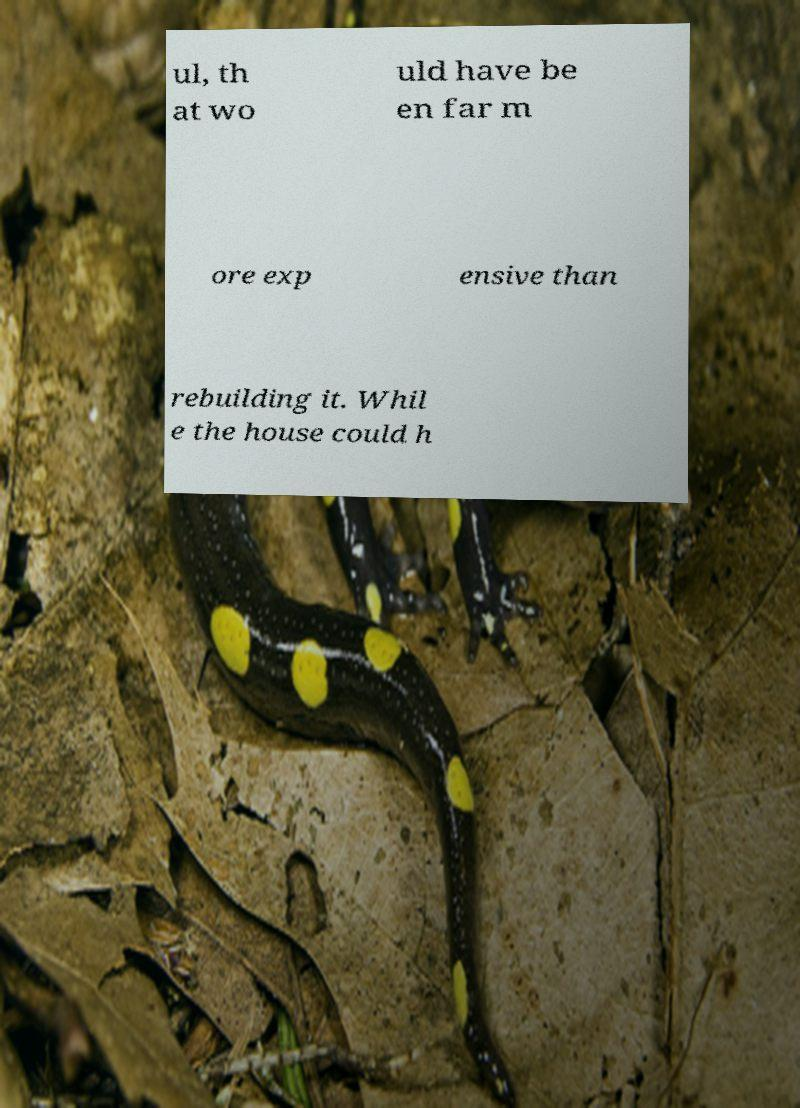Please identify and transcribe the text found in this image. ul, th at wo uld have be en far m ore exp ensive than rebuilding it. Whil e the house could h 